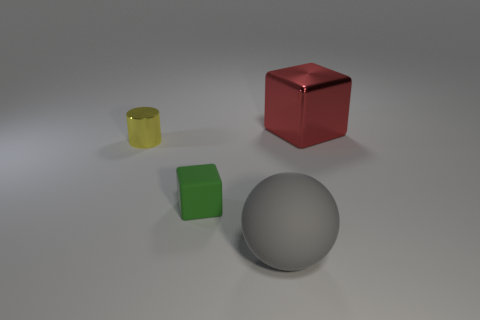There is a metallic cube that is the same size as the rubber sphere; what color is it?
Keep it short and to the point. Red. How big is the cube on the right side of the big object that is in front of the green matte thing?
Offer a very short reply. Large. Is the number of yellow shiny objects to the right of the sphere less than the number of red matte cylinders?
Offer a very short reply. No. How many other things are there of the same size as the gray rubber sphere?
Make the answer very short. 1. Is the shape of the metallic object to the right of the green cube the same as  the big rubber object?
Offer a very short reply. No. Are there more big objects in front of the big red metal thing than small gray spheres?
Ensure brevity in your answer.  Yes. What is the thing that is in front of the small shiny cylinder and on the right side of the tiny green rubber thing made of?
Provide a short and direct response. Rubber. Are there any other things that have the same shape as the yellow shiny thing?
Your answer should be very brief. No. What number of blocks are behind the tiny green rubber cube and left of the large gray thing?
Offer a very short reply. 0. What material is the red thing?
Your response must be concise. Metal. 